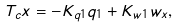Convert formula to latex. <formula><loc_0><loc_0><loc_500><loc_500>T _ { c } x = - K _ { q 1 } q _ { 1 } + K _ { w 1 } { w _ { x } } ,</formula> 